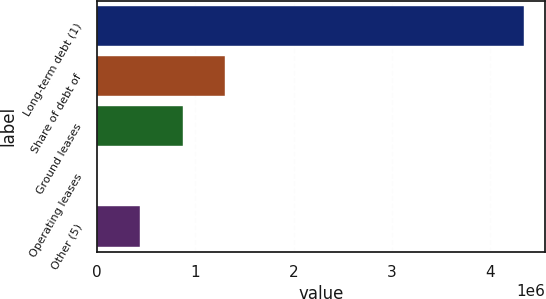Convert chart. <chart><loc_0><loc_0><loc_500><loc_500><bar_chart><fcel>Long-term debt (1)<fcel>Share of debt of<fcel>Ground leases<fcel>Operating leases<fcel>Other (5)<nl><fcel>4.33874e+06<fcel>1.30253e+06<fcel>868786<fcel>1297<fcel>435042<nl></chart> 